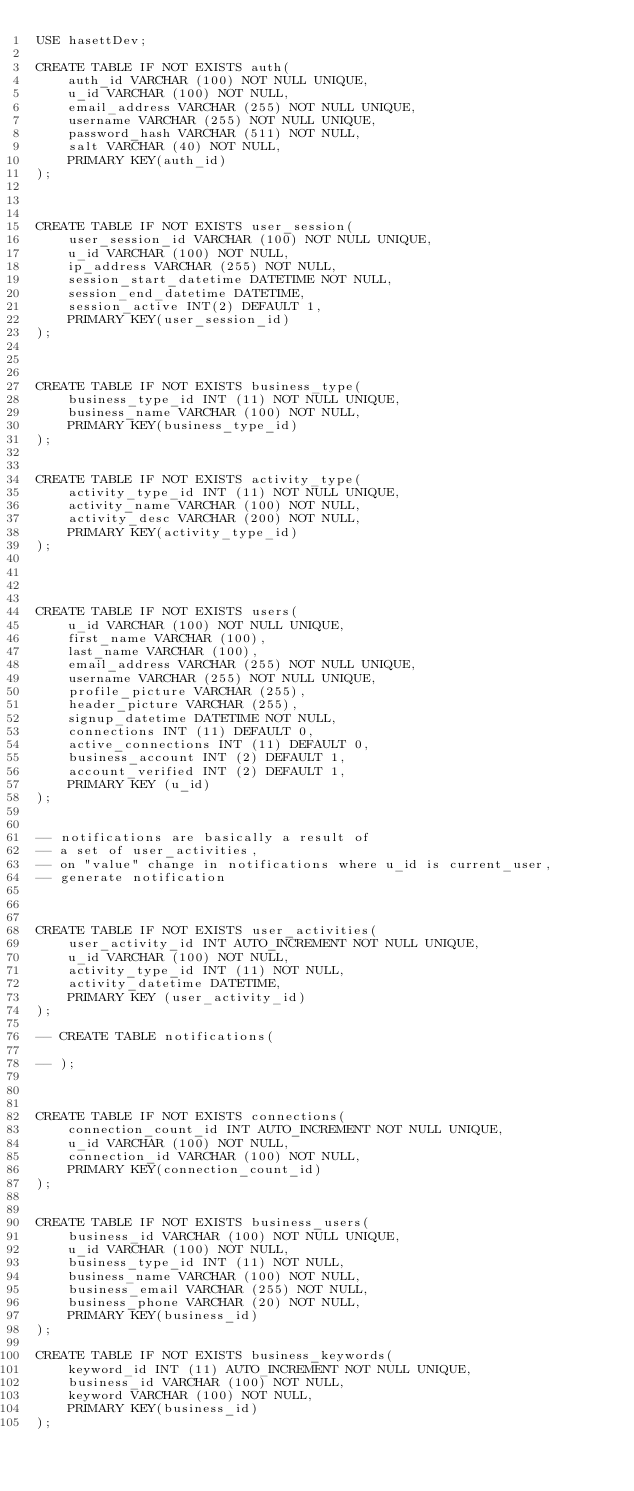Convert code to text. <code><loc_0><loc_0><loc_500><loc_500><_SQL_>USE hasettDev;

CREATE TABLE IF NOT EXISTS auth(
    auth_id VARCHAR (100) NOT NULL UNIQUE,
    u_id VARCHAR (100) NOT NULL,
    email_address VARCHAR (255) NOT NULL UNIQUE,
    username VARCHAR (255) NOT NULL UNIQUE,
    password_hash VARCHAR (511) NOT NULL,
    salt VARCHAR (40) NOT NULL,
    PRIMARY KEY(auth_id)
);



CREATE TABLE IF NOT EXISTS user_session(
    user_session_id VARCHAR (100) NOT NULL UNIQUE,
    u_id VARCHAR (100) NOT NULL,
    ip_address VARCHAR (255) NOT NULL,
    session_start_datetime DATETIME NOT NULL,
    session_end_datetime DATETIME,
    session_active INT(2) DEFAULT 1,
    PRIMARY KEY(user_session_id)
);



CREATE TABLE IF NOT EXISTS business_type(
    business_type_id INT (11) NOT NULL UNIQUE,
    business_name VARCHAR (100) NOT NULL,
    PRIMARY KEY(business_type_id)
);


CREATE TABLE IF NOT EXISTS activity_type(
    activity_type_id INT (11) NOT NULL UNIQUE,
    activity_name VARCHAR (100) NOT NULL,
    activity_desc VARCHAR (200) NOT NULL,
    PRIMARY KEY(activity_type_id)
);




CREATE TABLE IF NOT EXISTS users(
    u_id VARCHAR (100) NOT NULL UNIQUE,
    first_name VARCHAR (100),
    last_name VARCHAR (100),
    email_address VARCHAR (255) NOT NULL UNIQUE,
    username VARCHAR (255) NOT NULL UNIQUE,
    profile_picture VARCHAR (255),
    header_picture VARCHAR (255),
    signup_datetime DATETIME NOT NULL,
    connections INT (11) DEFAULT 0,
    active_connections INT (11) DEFAULT 0,
    business_account INT (2) DEFAULT 1,
    account_verified INT (2) DEFAULT 1,
    PRIMARY KEY (u_id)
); 


-- notifications are basically a result of 
-- a set of user_activities, 
-- on "value" change in notifications where u_id is current_user, 
-- generate notification



CREATE TABLE IF NOT EXISTS user_activities(
    user_activity_id INT AUTO_INCREMENT NOT NULL UNIQUE,
    u_id VARCHAR (100) NOT NULL,    
    activity_type_id INT (11) NOT NULL,
    activity_datetime DATETIME,
    PRIMARY KEY (user_activity_id)
);

-- CREATE TABLE notifications(
    
-- );



CREATE TABLE IF NOT EXISTS connections(
    connection_count_id INT AUTO_INCREMENT NOT NULL UNIQUE,
    u_id VARCHAR (100) NOT NULL,
    connection_id VARCHAR (100) NOT NULL,
    PRIMARY KEY(connection_count_id)
);


CREATE TABLE IF NOT EXISTS business_users(
    business_id VARCHAR (100) NOT NULL UNIQUE,
    u_id VARCHAR (100) NOT NULL,
    business_type_id INT (11) NOT NULL,
    business_name VARCHAR (100) NOT NULL,
    business_email VARCHAR (255) NOT NULL,
    business_phone VARCHAR (20) NOT NULL,
    PRIMARY KEY(business_id)
);

CREATE TABLE IF NOT EXISTS business_keywords(
    keyword_id INT (11) AUTO_INCREMENT NOT NULL UNIQUE,
    business_id VARCHAR (100) NOT NULL,
    keyword VARCHAR (100) NOT NULL,
    PRIMARY KEY(business_id)
);
</code> 